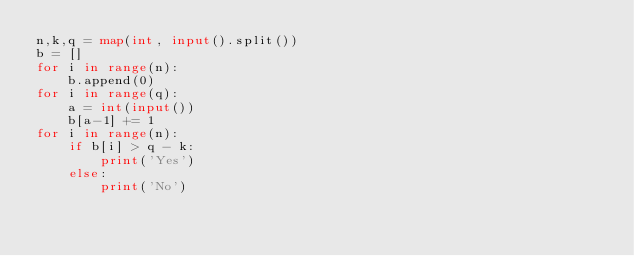Convert code to text. <code><loc_0><loc_0><loc_500><loc_500><_Python_>n,k,q = map(int, input().split())
b = []
for i in range(n):
    b.append(0)
for i in range(q):
    a = int(input())
    b[a-1] += 1
for i in range(n):
    if b[i] > q - k:
        print('Yes')
    else:
        print('No')</code> 